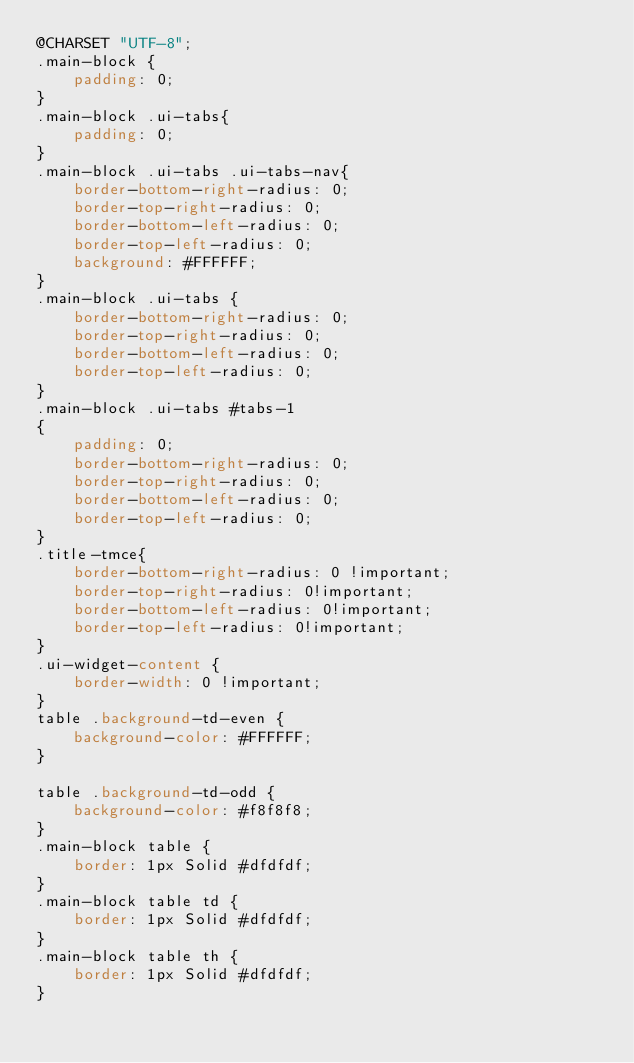<code> <loc_0><loc_0><loc_500><loc_500><_CSS_>@CHARSET "UTF-8";
.main-block {
    padding: 0;
}
.main-block .ui-tabs{
    padding: 0;
}
.main-block .ui-tabs .ui-tabs-nav{
    border-bottom-right-radius: 0;
    border-top-right-radius: 0;
    border-bottom-left-radius: 0;
    border-top-left-radius: 0;
    background: #FFFFFF;
}
.main-block .ui-tabs {
    border-bottom-right-radius: 0;
    border-top-right-radius: 0;
    border-bottom-left-radius: 0;
    border-top-left-radius: 0;
}
.main-block .ui-tabs #tabs-1
{
    padding: 0;
    border-bottom-right-radius: 0;
    border-top-right-radius: 0;
    border-bottom-left-radius: 0;
    border-top-left-radius: 0;
}
.title-tmce{
    border-bottom-right-radius: 0 !important;
    border-top-right-radius: 0!important;
    border-bottom-left-radius: 0!important;
    border-top-left-radius: 0!important;
}
.ui-widget-content {
    border-width: 0 !important;
}
table .background-td-even {
    background-color: #FFFFFF;
}

table .background-td-odd {
    background-color: #f8f8f8;
}
.main-block table {
    border: 1px Solid #dfdfdf;
}
.main-block table td {
    border: 1px Solid #dfdfdf;
}
.main-block table th {
    border: 1px Solid #dfdfdf;
}</code> 